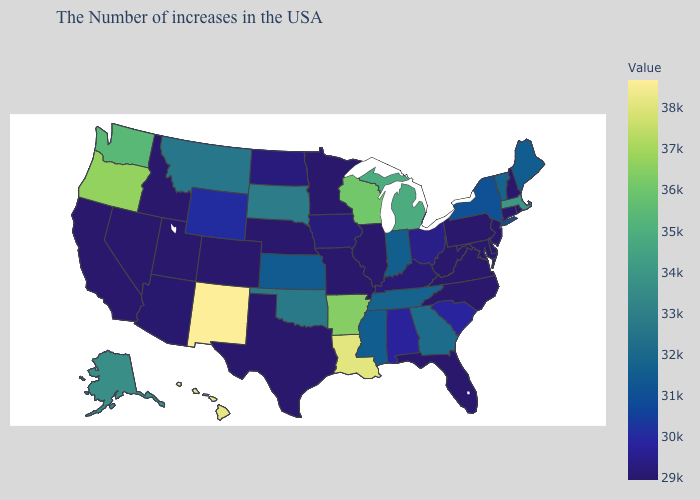Does New Mexico have the highest value in the USA?
Give a very brief answer. Yes. Among the states that border Maryland , which have the lowest value?
Answer briefly. Delaware, Pennsylvania, Virginia, West Virginia. Among the states that border Wisconsin , which have the highest value?
Concise answer only. Michigan. Does California have a higher value than New Mexico?
Be succinct. No. 